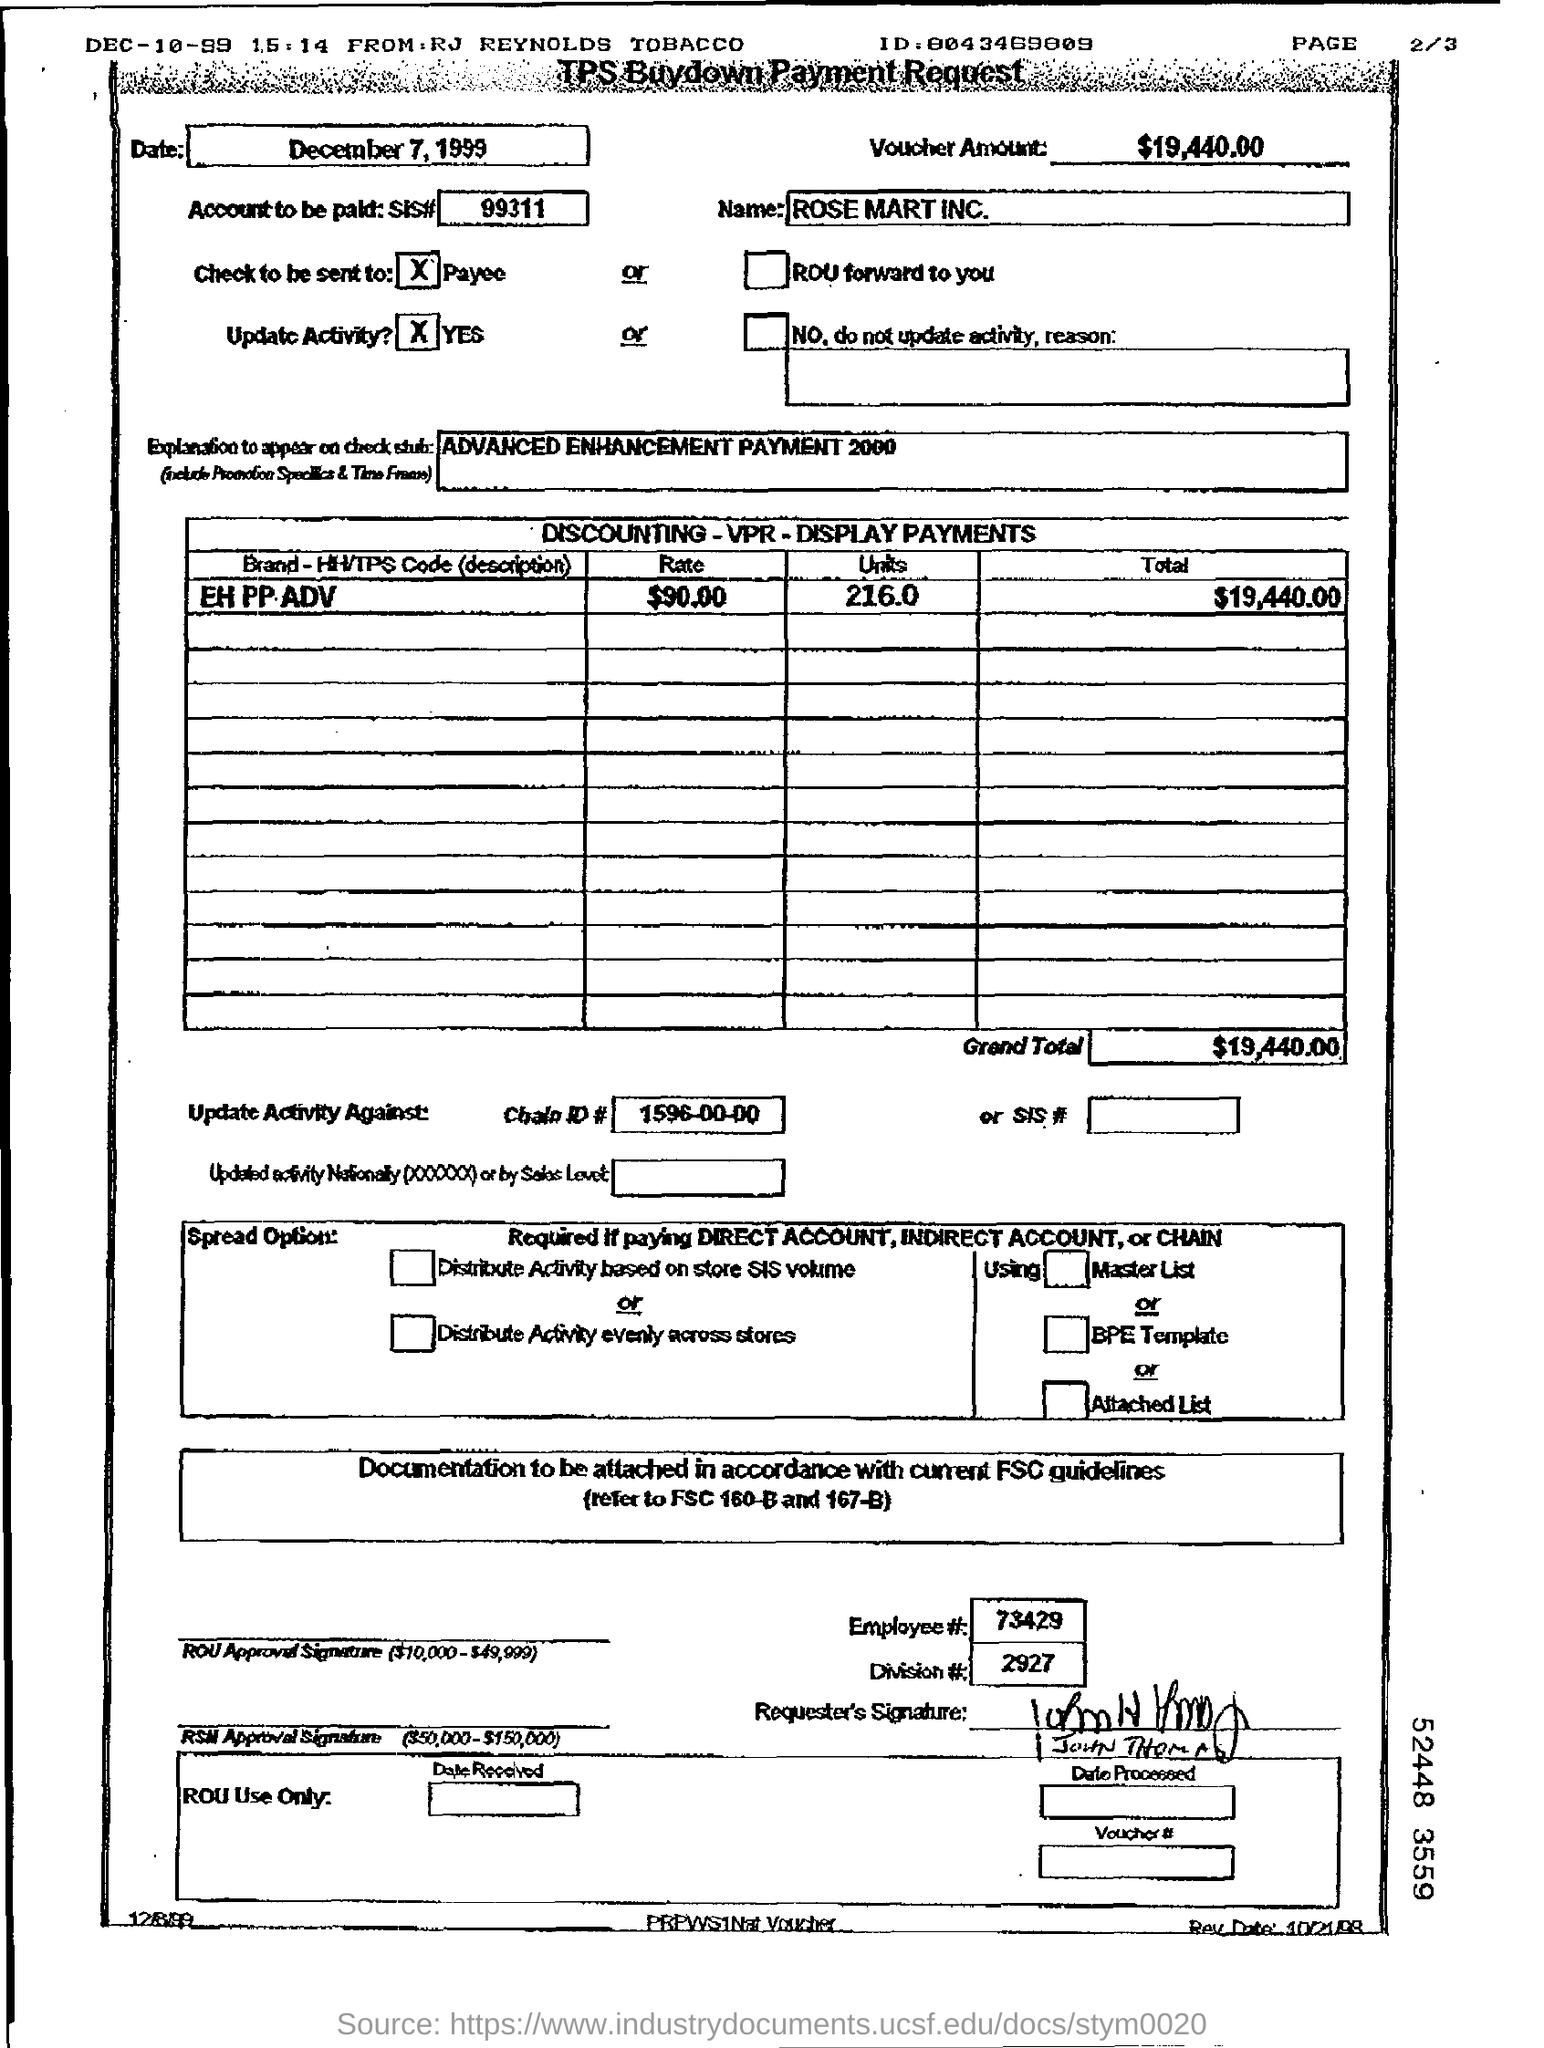What is the date written on the top left box?
Your answer should be compact. December 7, 1999. What is the voucher amount?
Your answer should be very brief. $19,440.00. What is Employee #? mentioned at the bottom of the document?
Your answer should be compact. 73429. 